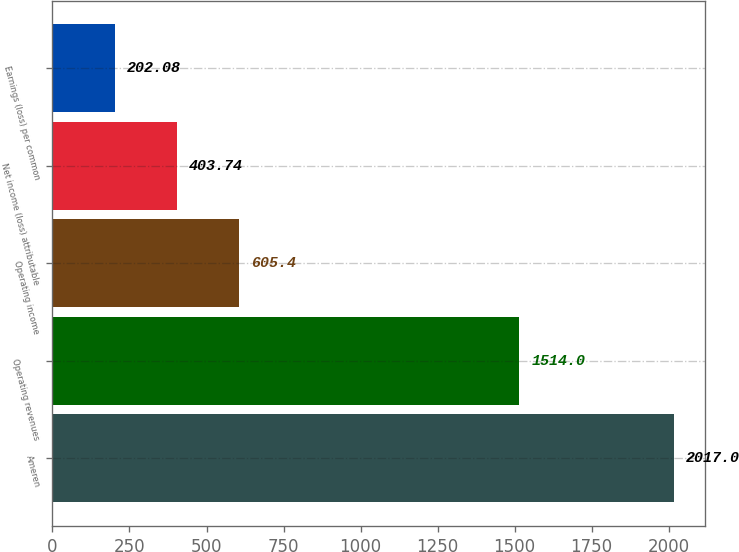Convert chart. <chart><loc_0><loc_0><loc_500><loc_500><bar_chart><fcel>Ameren<fcel>Operating revenues<fcel>Operating income<fcel>Net income (loss) attributable<fcel>Earnings (loss) per common<nl><fcel>2017<fcel>1514<fcel>605.4<fcel>403.74<fcel>202.08<nl></chart> 